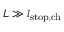<formula> <loc_0><loc_0><loc_500><loc_500>L \gg l _ { s t o p , c h }</formula> 